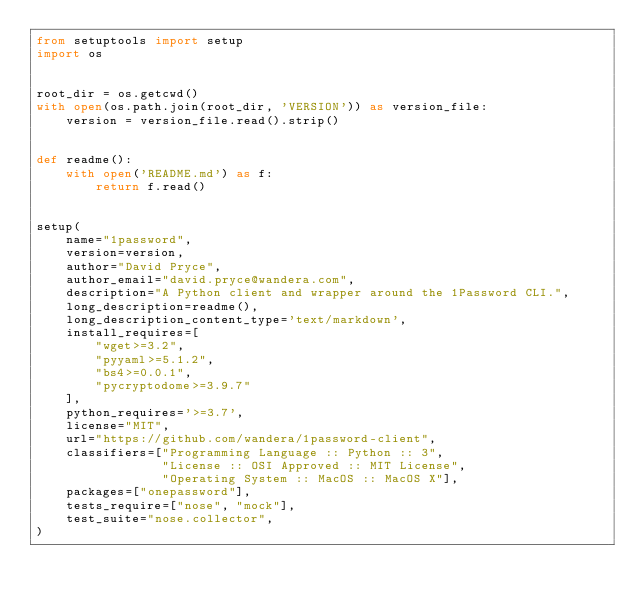<code> <loc_0><loc_0><loc_500><loc_500><_Python_>from setuptools import setup
import os


root_dir = os.getcwd()
with open(os.path.join(root_dir, 'VERSION')) as version_file:
    version = version_file.read().strip()


def readme():
    with open('README.md') as f:
        return f.read()


setup(
    name="1password",
    version=version,
    author="David Pryce",
    author_email="david.pryce@wandera.com",
    description="A Python client and wrapper around the 1Password CLI.",
    long_description=readme(),
    long_description_content_type='text/markdown',
    install_requires=[
        "wget>=3.2",
        "pyyaml>=5.1.2",
        "bs4>=0.0.1",
        "pycryptodome>=3.9.7"
    ],
    python_requires='>=3.7',
    license="MIT",
    url="https://github.com/wandera/1password-client",
    classifiers=["Programming Language :: Python :: 3",
                 "License :: OSI Approved :: MIT License",
                 "Operating System :: MacOS :: MacOS X"],
    packages=["onepassword"],
    tests_require=["nose", "mock"],
    test_suite="nose.collector",
)
</code> 